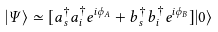<formula> <loc_0><loc_0><loc_500><loc_500>| \Psi \rangle \simeq [ a ^ { \dag } _ { s } a ^ { \dag } _ { i } e ^ { i \phi _ { A } } + b ^ { \dag } _ { s } b ^ { \dag } _ { i } e ^ { i \phi _ { B } } ] | 0 \rangle</formula> 